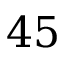<formula> <loc_0><loc_0><loc_500><loc_500>4 5</formula> 